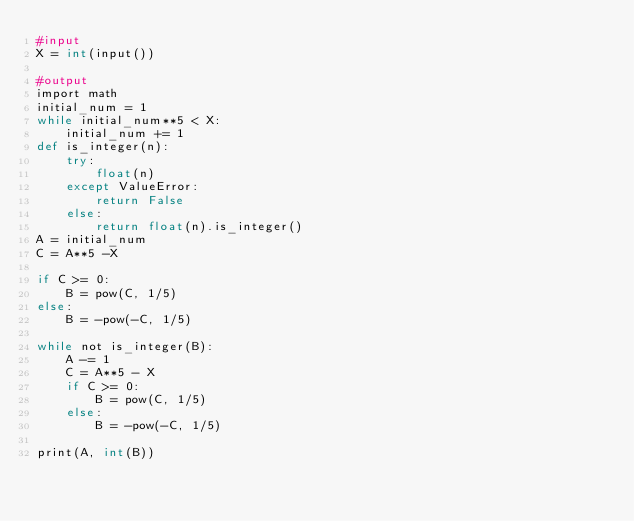<code> <loc_0><loc_0><loc_500><loc_500><_Cython_>#input
X = int(input())

#output
import math
initial_num = 1
while initial_num**5 < X:
    initial_num += 1
def is_integer(n):
    try:
        float(n)
    except ValueError:
        return False
    else:
        return float(n).is_integer()
A = initial_num
C = A**5 -X

if C >= 0:
    B = pow(C, 1/5)
else:
    B = -pow(-C, 1/5)

while not is_integer(B):
    A -= 1
    C = A**5 - X
    if C >= 0:
        B = pow(C, 1/5)
    else:
        B = -pow(-C, 1/5)

print(A, int(B))</code> 